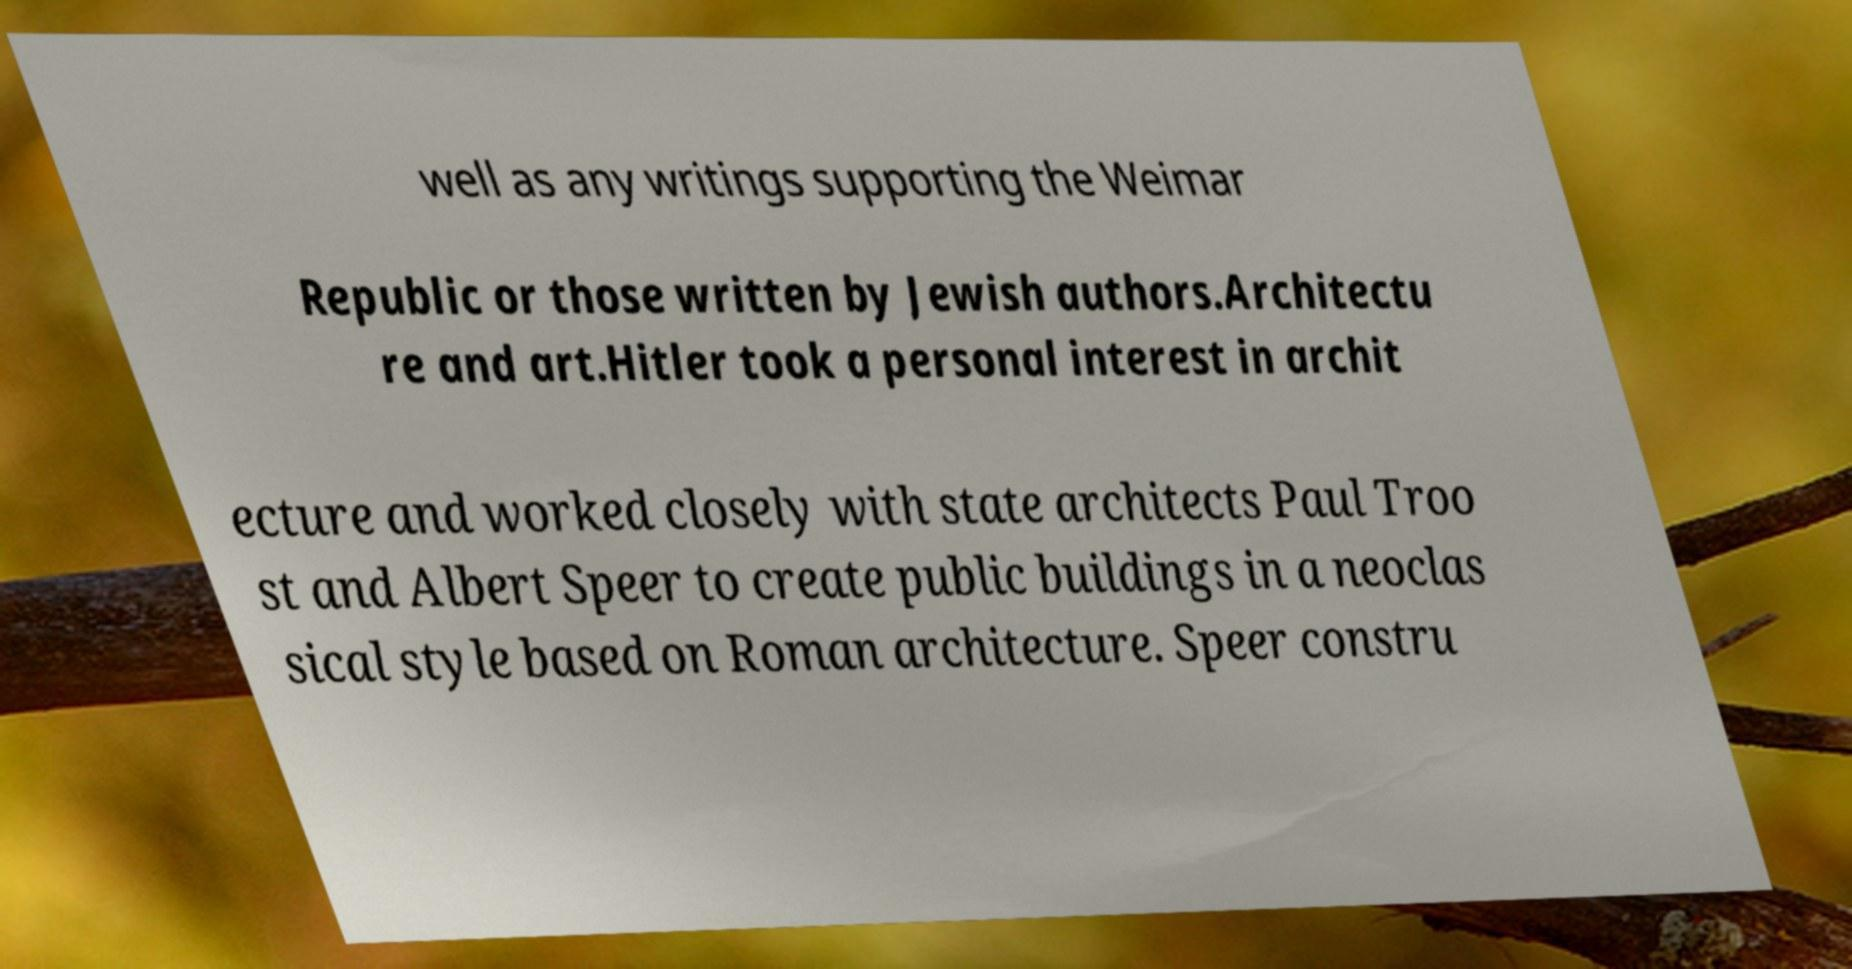Can you accurately transcribe the text from the provided image for me? well as any writings supporting the Weimar Republic or those written by Jewish authors.Architectu re and art.Hitler took a personal interest in archit ecture and worked closely with state architects Paul Troo st and Albert Speer to create public buildings in a neoclas sical style based on Roman architecture. Speer constru 